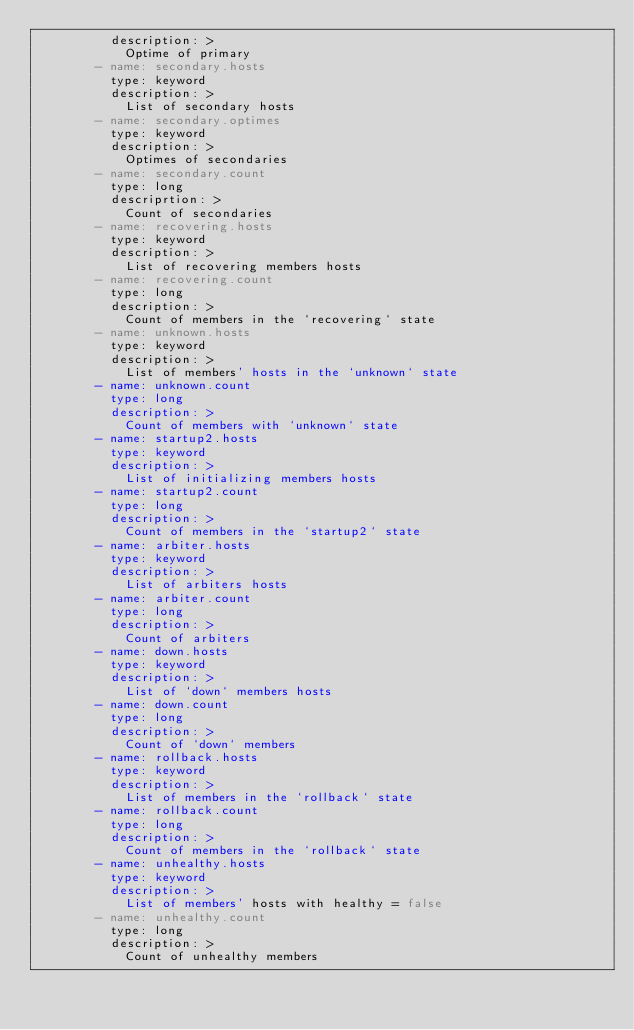Convert code to text. <code><loc_0><loc_0><loc_500><loc_500><_YAML_>          description: >
            Optime of primary
        - name: secondary.hosts
          type: keyword
          description: >
            List of secondary hosts
        - name: secondary.optimes
          type: keyword
          description: >
            Optimes of secondaries
        - name: secondary.count
          type: long
          descriprtion: >
            Count of secondaries
        - name: recovering.hosts
          type: keyword
          description: >
            List of recovering members hosts
        - name: recovering.count
          type: long
          description: >
            Count of members in the `recovering` state
        - name: unknown.hosts
          type: keyword
          description: >
            List of members' hosts in the `unknown` state
        - name: unknown.count
          type: long
          description: >
            Count of members with `unknown` state
        - name: startup2.hosts
          type: keyword
          description: >
            List of initializing members hosts
        - name: startup2.count
          type: long
          description: >
            Count of members in the `startup2` state
        - name: arbiter.hosts
          type: keyword
          description: >
            List of arbiters hosts
        - name: arbiter.count
          type: long
          description: >
            Count of arbiters
        - name: down.hosts
          type: keyword
          description: >
            List of `down` members hosts
        - name: down.count
          type: long
          description: >
            Count of `down` members
        - name: rollback.hosts
          type: keyword
          description: >
            List of members in the `rollback` state
        - name: rollback.count
          type: long
          description: >
            Count of members in the `rollback` state
        - name: unhealthy.hosts
          type: keyword
          description: >
            List of members' hosts with healthy = false
        - name: unhealthy.count
          type: long
          description: >
            Count of unhealthy members
</code> 